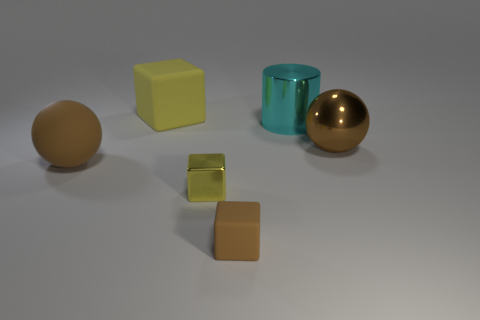What shape is the cyan shiny object behind the yellow object that is in front of the large sphere that is on the left side of the small yellow object?
Offer a very short reply. Cylinder. Do the small thing that is in front of the small yellow shiny cube and the big ball that is to the right of the small brown matte thing have the same color?
Your answer should be very brief. Yes. Is the number of big things on the left side of the big brown rubber ball less than the number of big yellow things behind the tiny rubber object?
Your answer should be compact. Yes. Is there anything else that has the same shape as the small rubber object?
Make the answer very short. Yes. What is the color of the tiny metal object that is the same shape as the big yellow object?
Give a very brief answer. Yellow. There is a large yellow object; is it the same shape as the small thing that is in front of the metal cube?
Ensure brevity in your answer.  Yes. What number of objects are either brown spheres right of the big metallic cylinder or cubes that are in front of the large cube?
Offer a very short reply. 3. What material is the big yellow thing?
Give a very brief answer. Rubber. How many other things are there of the same size as the yellow metallic block?
Give a very brief answer. 1. How big is the cyan object to the right of the yellow shiny thing?
Keep it short and to the point. Large. 